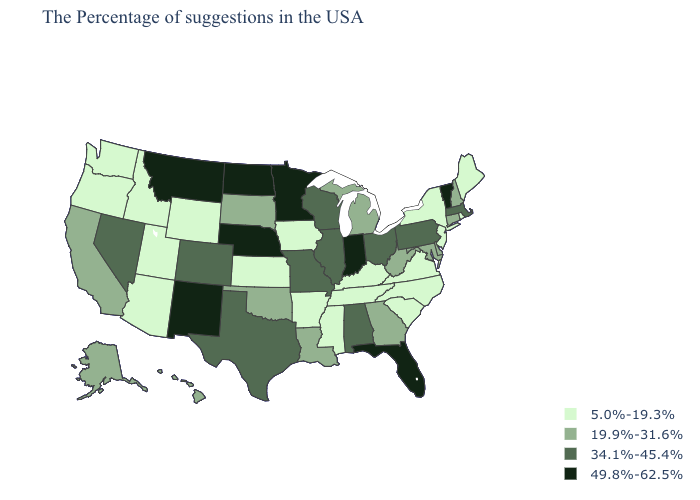Name the states that have a value in the range 34.1%-45.4%?
Short answer required. Massachusetts, Pennsylvania, Ohio, Alabama, Wisconsin, Illinois, Missouri, Texas, Colorado, Nevada. What is the value of Arkansas?
Quick response, please. 5.0%-19.3%. What is the value of Florida?
Give a very brief answer. 49.8%-62.5%. What is the lowest value in the USA?
Write a very short answer. 5.0%-19.3%. Among the states that border Kentucky , does Illinois have the lowest value?
Concise answer only. No. Which states have the lowest value in the Northeast?
Write a very short answer. Maine, Rhode Island, New York, New Jersey. Which states have the lowest value in the USA?
Write a very short answer. Maine, Rhode Island, New York, New Jersey, Virginia, North Carolina, South Carolina, Kentucky, Tennessee, Mississippi, Arkansas, Iowa, Kansas, Wyoming, Utah, Arizona, Idaho, Washington, Oregon. Name the states that have a value in the range 49.8%-62.5%?
Short answer required. Vermont, Florida, Indiana, Minnesota, Nebraska, North Dakota, New Mexico, Montana. Does the map have missing data?
Keep it brief. No. What is the lowest value in the West?
Concise answer only. 5.0%-19.3%. What is the value of Oklahoma?
Concise answer only. 19.9%-31.6%. Which states have the highest value in the USA?
Answer briefly. Vermont, Florida, Indiana, Minnesota, Nebraska, North Dakota, New Mexico, Montana. What is the value of New Mexico?
Answer briefly. 49.8%-62.5%. What is the value of Florida?
Answer briefly. 49.8%-62.5%. 